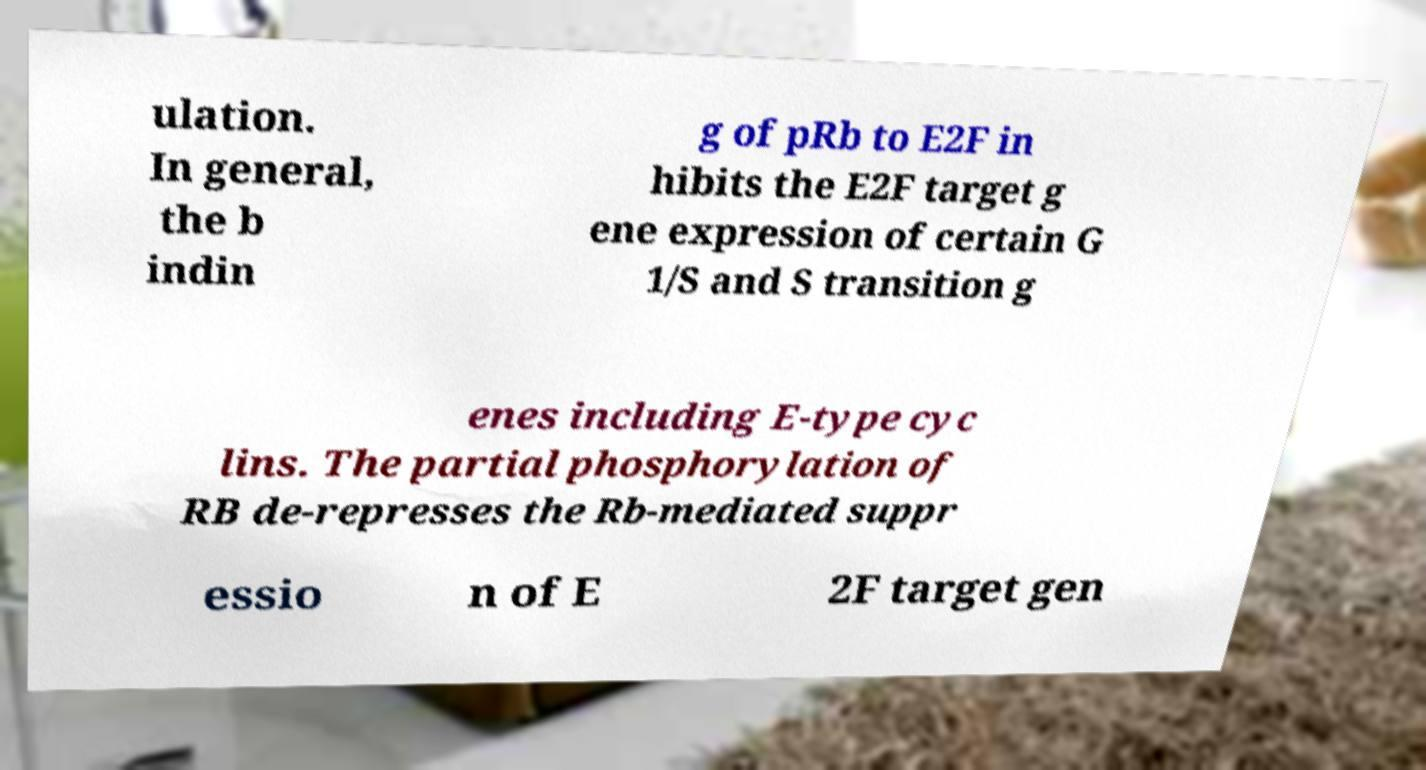Could you assist in decoding the text presented in this image and type it out clearly? ulation. In general, the b indin g of pRb to E2F in hibits the E2F target g ene expression of certain G 1/S and S transition g enes including E-type cyc lins. The partial phosphorylation of RB de-represses the Rb-mediated suppr essio n of E 2F target gen 